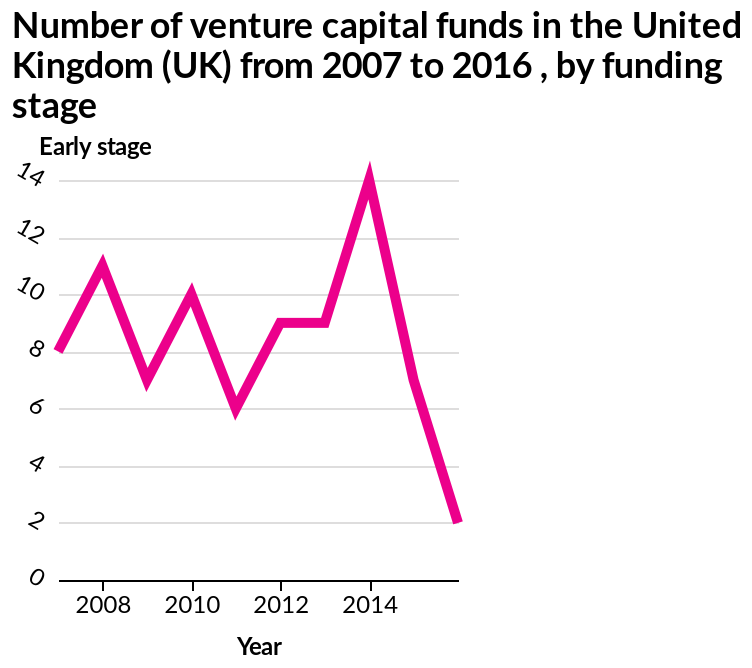<image>
please summary the statistics and relations of the chart Between 2007 and 2013 we see some fluctuations year on year in number of venture capital funds in the UK. During this period there seems to be a trend of increasing one year (e.g. from 8 in 2007 to 11 in 2008) and decreasing the next (e.g from 11 in 2008 to 7 in 2009). The overall trend during this period however is a gradual decline in funds. We then see a huge increase in 2014 where the number spikes at 14, before reapidly declining with only 2 funds in the UK in 2016. 